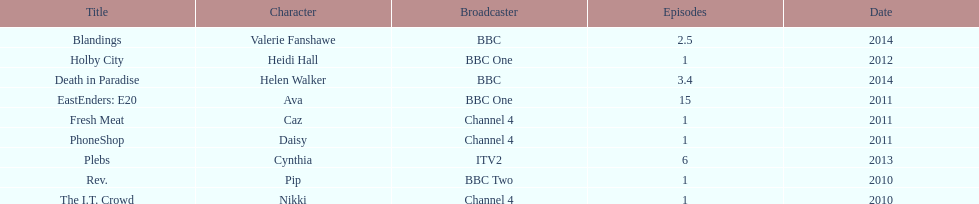What is the total number of shows sophie colguhoun appeared in? 9. 